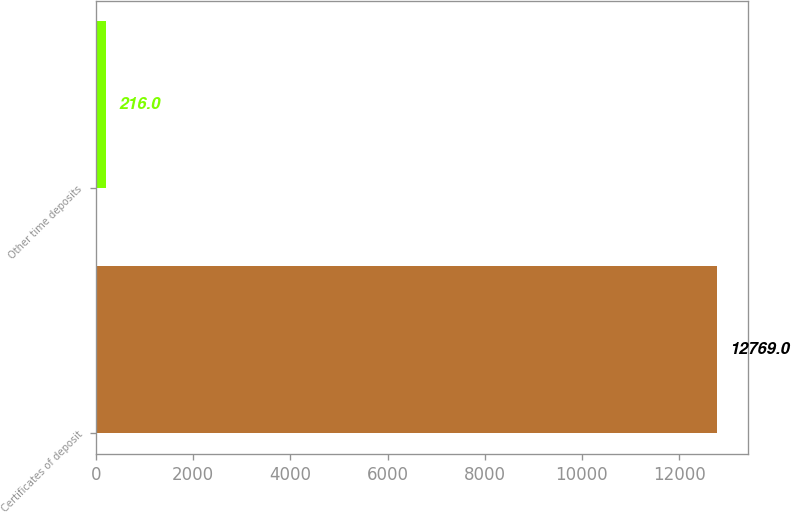Convert chart. <chart><loc_0><loc_0><loc_500><loc_500><bar_chart><fcel>Certificates of deposit<fcel>Other time deposits<nl><fcel>12769<fcel>216<nl></chart> 